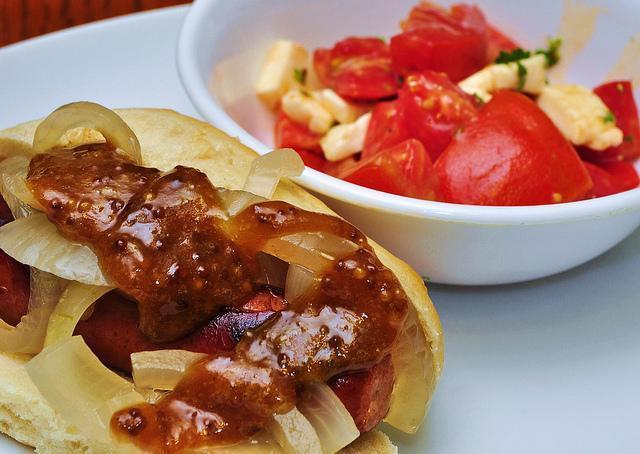How many birds have their wings spread?
Give a very brief answer. 0. 